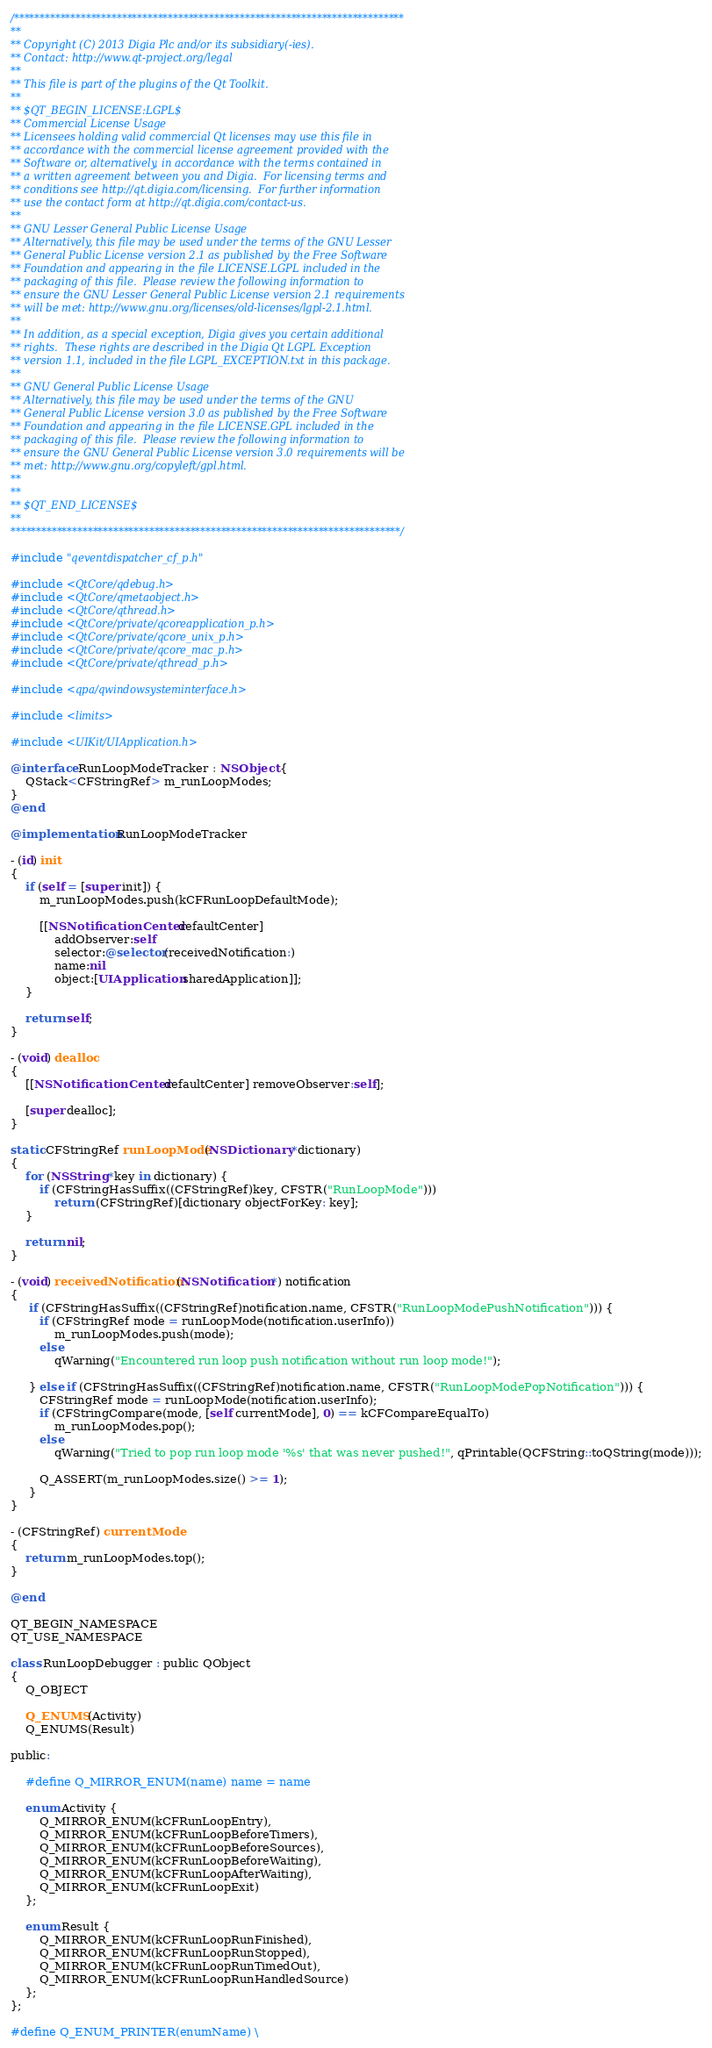Convert code to text. <code><loc_0><loc_0><loc_500><loc_500><_ObjectiveC_>/****************************************************************************
**
** Copyright (C) 2013 Digia Plc and/or its subsidiary(-ies).
** Contact: http://www.qt-project.org/legal
**
** This file is part of the plugins of the Qt Toolkit.
**
** $QT_BEGIN_LICENSE:LGPL$
** Commercial License Usage
** Licensees holding valid commercial Qt licenses may use this file in
** accordance with the commercial license agreement provided with the
** Software or, alternatively, in accordance with the terms contained in
** a written agreement between you and Digia.  For licensing terms and
** conditions see http://qt.digia.com/licensing.  For further information
** use the contact form at http://qt.digia.com/contact-us.
**
** GNU Lesser General Public License Usage
** Alternatively, this file may be used under the terms of the GNU Lesser
** General Public License version 2.1 as published by the Free Software
** Foundation and appearing in the file LICENSE.LGPL included in the
** packaging of this file.  Please review the following information to
** ensure the GNU Lesser General Public License version 2.1 requirements
** will be met: http://www.gnu.org/licenses/old-licenses/lgpl-2.1.html.
**
** In addition, as a special exception, Digia gives you certain additional
** rights.  These rights are described in the Digia Qt LGPL Exception
** version 1.1, included in the file LGPL_EXCEPTION.txt in this package.
**
** GNU General Public License Usage
** Alternatively, this file may be used under the terms of the GNU
** General Public License version 3.0 as published by the Free Software
** Foundation and appearing in the file LICENSE.GPL included in the
** packaging of this file.  Please review the following information to
** ensure the GNU General Public License version 3.0 requirements will be
** met: http://www.gnu.org/copyleft/gpl.html.
**
**
** $QT_END_LICENSE$
**
****************************************************************************/

#include "qeventdispatcher_cf_p.h"

#include <QtCore/qdebug.h>
#include <QtCore/qmetaobject.h>
#include <QtCore/qthread.h>
#include <QtCore/private/qcoreapplication_p.h>
#include <QtCore/private/qcore_unix_p.h>
#include <QtCore/private/qcore_mac_p.h>
#include <QtCore/private/qthread_p.h>

#include <qpa/qwindowsysteminterface.h>

#include <limits>

#include <UIKit/UIApplication.h>

@interface RunLoopModeTracker : NSObject {
    QStack<CFStringRef> m_runLoopModes;
}
@end

@implementation RunLoopModeTracker

- (id) init
{
    if (self = [super init]) {
        m_runLoopModes.push(kCFRunLoopDefaultMode);

        [[NSNotificationCenter defaultCenter]
            addObserver:self
            selector:@selector(receivedNotification:)
            name:nil
            object:[UIApplication sharedApplication]];
    }

    return self;
}

- (void) dealloc
{
    [[NSNotificationCenter defaultCenter] removeObserver:self];

    [super dealloc];
}

static CFStringRef runLoopMode(NSDictionary *dictionary)
{
    for (NSString *key in dictionary) {
        if (CFStringHasSuffix((CFStringRef)key, CFSTR("RunLoopMode")))
            return (CFStringRef)[dictionary objectForKey: key];
    }

    return nil;
}

- (void) receivedNotification:(NSNotification *) notification
{
     if (CFStringHasSuffix((CFStringRef)notification.name, CFSTR("RunLoopModePushNotification"))) {
        if (CFStringRef mode = runLoopMode(notification.userInfo))
            m_runLoopModes.push(mode);
        else
            qWarning("Encountered run loop push notification without run loop mode!");

     } else if (CFStringHasSuffix((CFStringRef)notification.name, CFSTR("RunLoopModePopNotification"))) {
        CFStringRef mode = runLoopMode(notification.userInfo);
        if (CFStringCompare(mode, [self currentMode], 0) == kCFCompareEqualTo)
            m_runLoopModes.pop();
        else
            qWarning("Tried to pop run loop mode '%s' that was never pushed!", qPrintable(QCFString::toQString(mode)));

        Q_ASSERT(m_runLoopModes.size() >= 1);
     }
}

- (CFStringRef) currentMode
{
    return m_runLoopModes.top();
}

@end

QT_BEGIN_NAMESPACE
QT_USE_NAMESPACE

class RunLoopDebugger : public QObject
{
    Q_OBJECT

    Q_ENUMS(Activity)
    Q_ENUMS(Result)

public:

    #define Q_MIRROR_ENUM(name) name = name

    enum Activity {
        Q_MIRROR_ENUM(kCFRunLoopEntry),
        Q_MIRROR_ENUM(kCFRunLoopBeforeTimers),
        Q_MIRROR_ENUM(kCFRunLoopBeforeSources),
        Q_MIRROR_ENUM(kCFRunLoopBeforeWaiting),
        Q_MIRROR_ENUM(kCFRunLoopAfterWaiting),
        Q_MIRROR_ENUM(kCFRunLoopExit)
    };

    enum Result {
        Q_MIRROR_ENUM(kCFRunLoopRunFinished),
        Q_MIRROR_ENUM(kCFRunLoopRunStopped),
        Q_MIRROR_ENUM(kCFRunLoopRunTimedOut),
        Q_MIRROR_ENUM(kCFRunLoopRunHandledSource)
    };
};

#define Q_ENUM_PRINTER(enumName) \</code> 